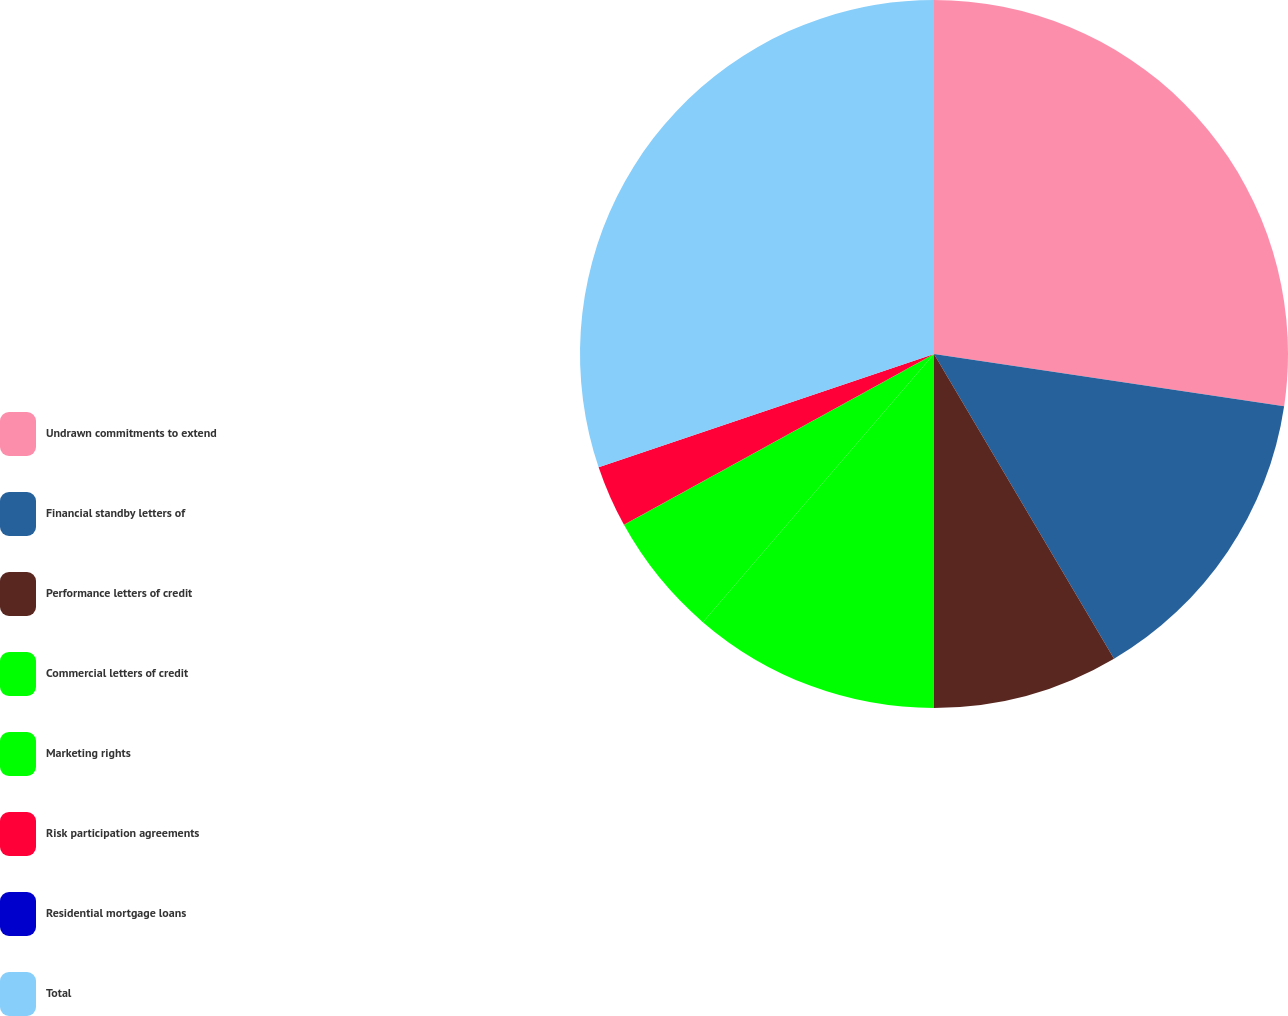Convert chart. <chart><loc_0><loc_0><loc_500><loc_500><pie_chart><fcel>Undrawn commitments to extend<fcel>Financial standby letters of<fcel>Performance letters of credit<fcel>Commercial letters of credit<fcel>Marketing rights<fcel>Risk participation agreements<fcel>Residential mortgage loans<fcel>Total<nl><fcel>27.35%<fcel>14.15%<fcel>8.49%<fcel>11.32%<fcel>5.66%<fcel>2.83%<fcel>0.0%<fcel>30.18%<nl></chart> 